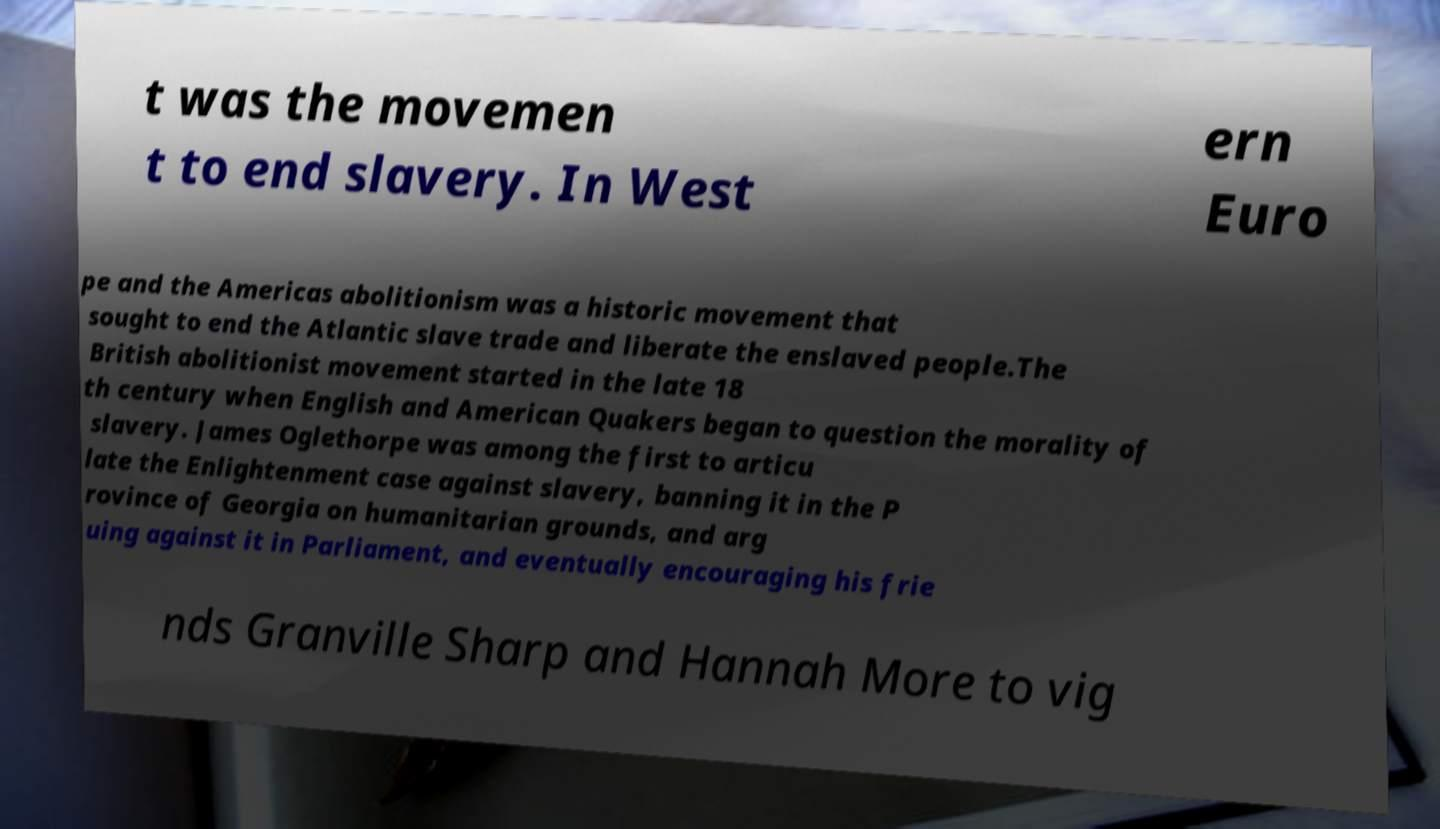Could you extract and type out the text from this image? t was the movemen t to end slavery. In West ern Euro pe and the Americas abolitionism was a historic movement that sought to end the Atlantic slave trade and liberate the enslaved people.The British abolitionist movement started in the late 18 th century when English and American Quakers began to question the morality of slavery. James Oglethorpe was among the first to articu late the Enlightenment case against slavery, banning it in the P rovince of Georgia on humanitarian grounds, and arg uing against it in Parliament, and eventually encouraging his frie nds Granville Sharp and Hannah More to vig 